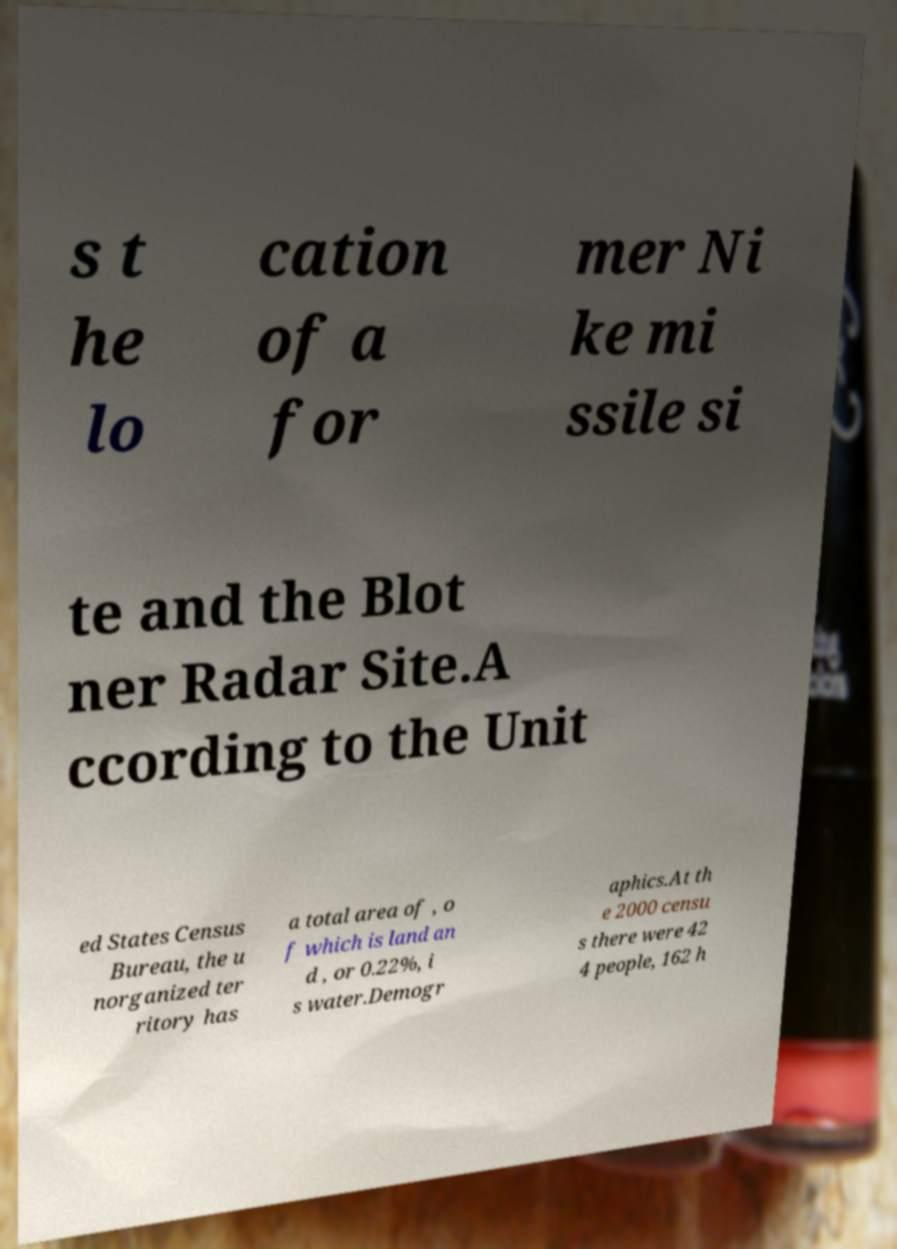For documentation purposes, I need the text within this image transcribed. Could you provide that? s t he lo cation of a for mer Ni ke mi ssile si te and the Blot ner Radar Site.A ccording to the Unit ed States Census Bureau, the u norganized ter ritory has a total area of , o f which is land an d , or 0.22%, i s water.Demogr aphics.At th e 2000 censu s there were 42 4 people, 162 h 